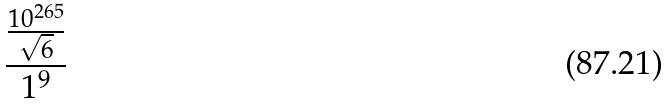<formula> <loc_0><loc_0><loc_500><loc_500>\frac { \frac { 1 0 ^ { 2 6 5 } } { \sqrt { 6 } } } { 1 ^ { 9 } }</formula> 